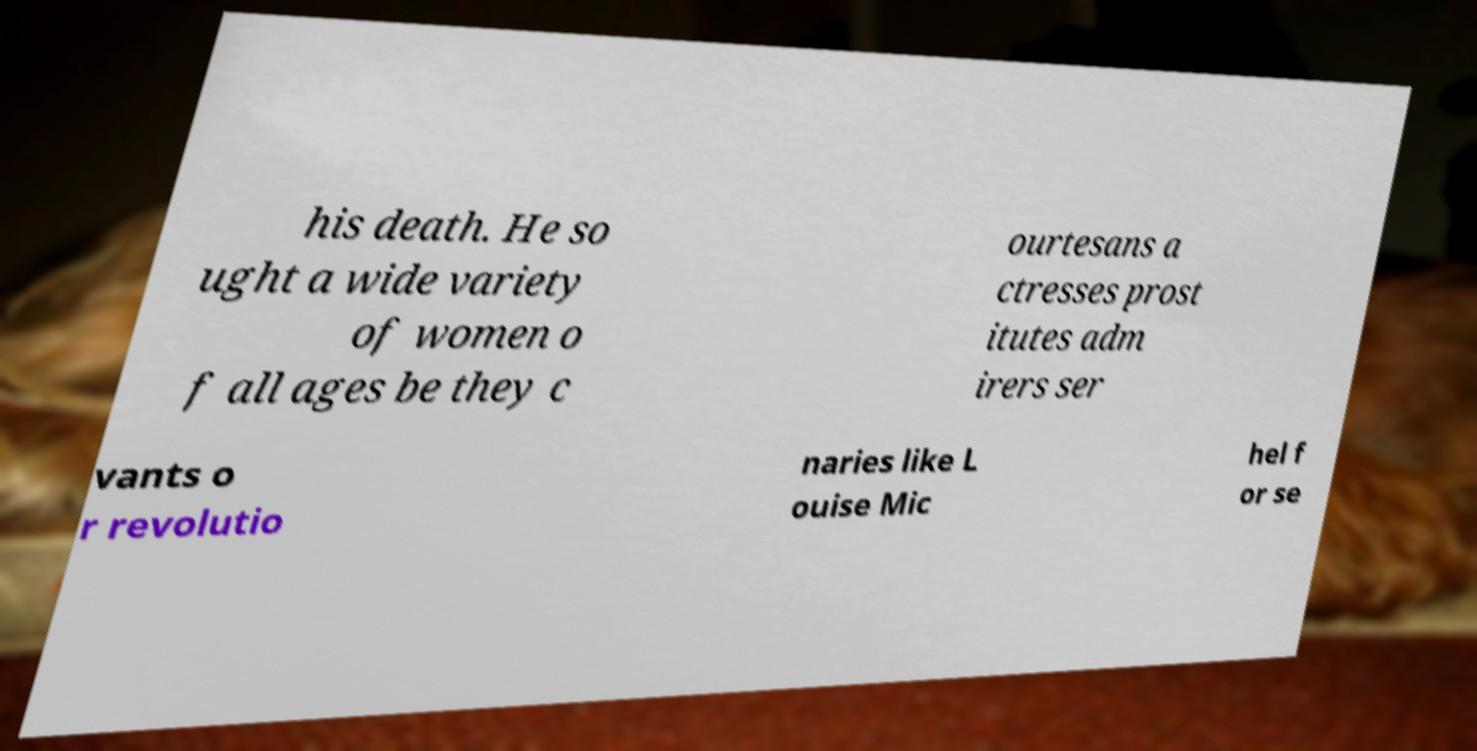Can you accurately transcribe the text from the provided image for me? his death. He so ught a wide variety of women o f all ages be they c ourtesans a ctresses prost itutes adm irers ser vants o r revolutio naries like L ouise Mic hel f or se 